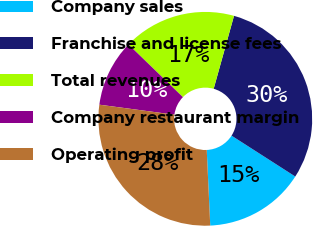<chart> <loc_0><loc_0><loc_500><loc_500><pie_chart><fcel>Company sales<fcel>Franchise and license fees<fcel>Total revenues<fcel>Company restaurant margin<fcel>Operating profit<nl><fcel>15.19%<fcel>29.75%<fcel>17.09%<fcel>10.13%<fcel>27.85%<nl></chart> 